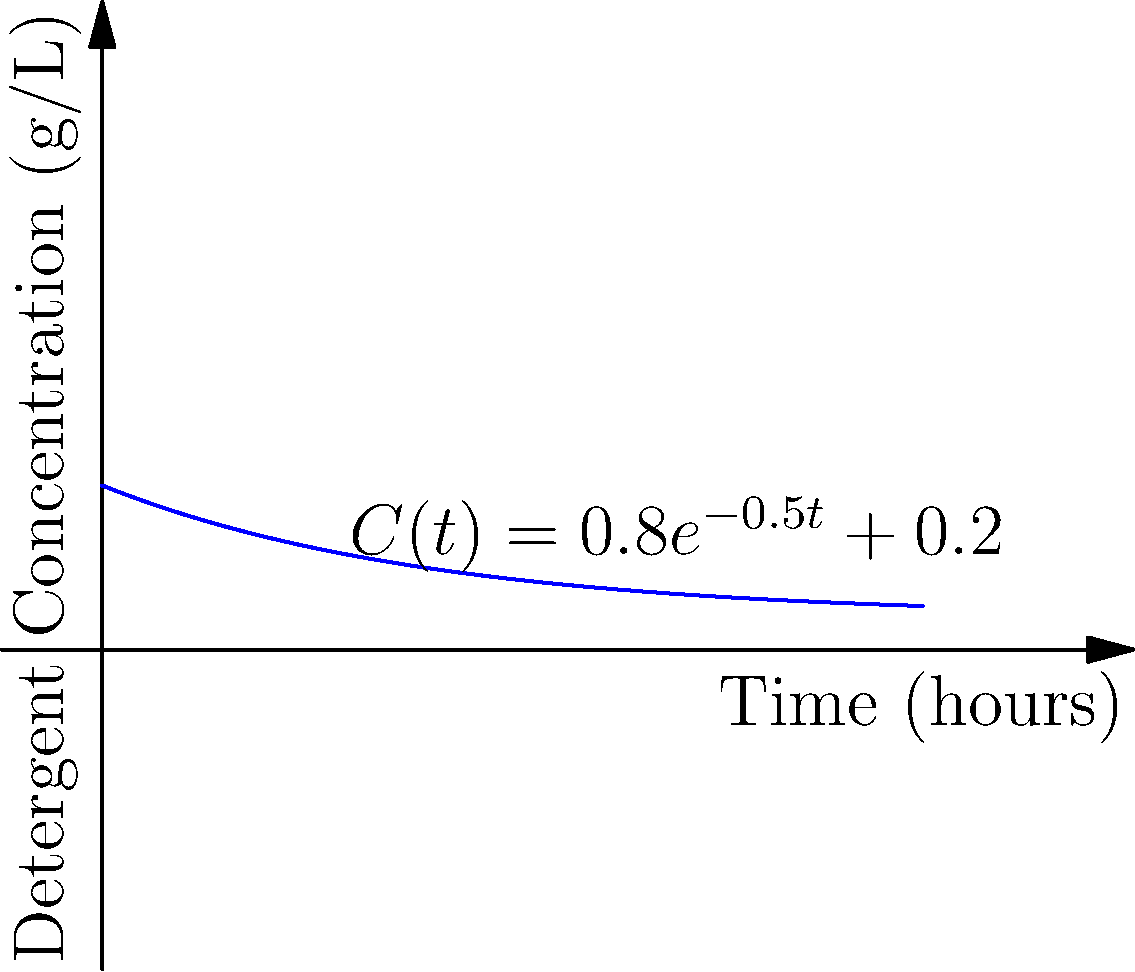As an appliance troubleshooting expert, you're advising on optimal detergent use. The concentration of detergent in a washing machine over time is given by the function $C(t) = 0.8e^{-0.5t} + 0.2$, where $C$ is in g/L and $t$ is in hours. Calculate the average concentration of detergent over the first 4 hours of the wash cycle. To find the average concentration over the first 4 hours, we need to:

1) Set up the definite integral to calculate the area under the curve:
   $\text{Average} = \frac{1}{4-0} \int_0^4 C(t) dt$

2) Substitute the function:
   $\text{Average} = \frac{1}{4} \int_0^4 (0.8e^{-0.5t} + 0.2) dt$

3) Integrate:
   $\text{Average} = \frac{1}{4} [(-1.6e^{-0.5t}) + 0.2t]_0^4$

4) Evaluate the integral:
   $\text{Average} = \frac{1}{4} [(-1.6e^{-0.5(4)} + 0.2(4)) - (-1.6e^{-0.5(0)} + 0.2(0))]$
   $= \frac{1}{4} [(-1.6(0.1353) + 0.8) - (-1.6 + 0)]$
   $= \frac{1}{4} [-0.2165 + 0.8 + 1.6]$
   $= \frac{1}{4} [2.1835]$
   $= 0.5459$

5) Round to three decimal places:
   $\text{Average} \approx 0.546$ g/L
Answer: 0.546 g/L 